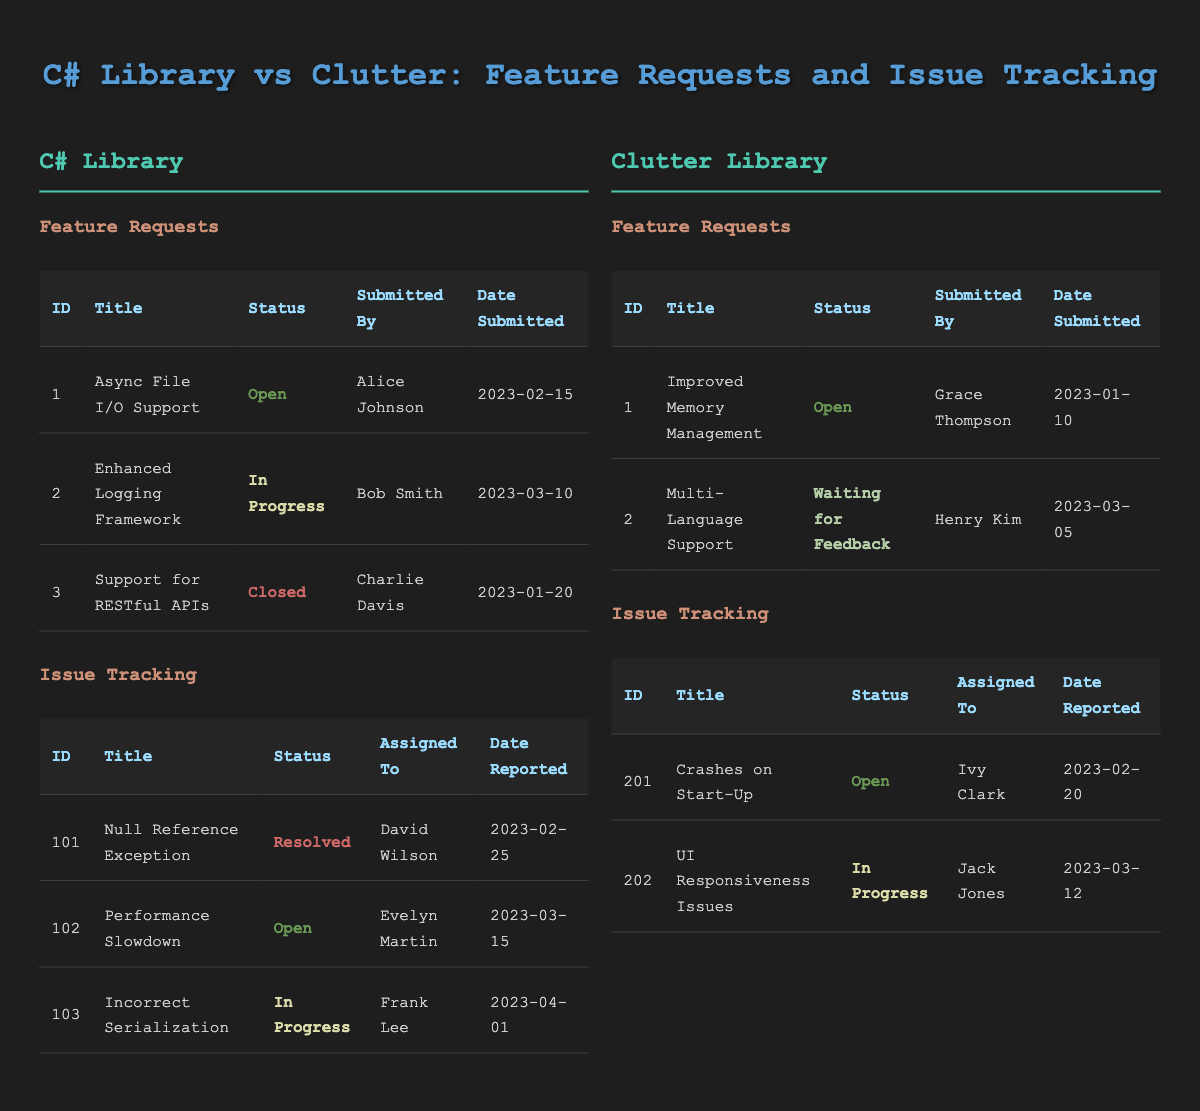What is the title of the first feature request for the C# library? The first feature request in the C# library feature requests table has an ID of 1. Looking at the corresponding title in that row, it is "Async File I/O Support."
Answer: Async File I/O Support How many feature requests are currently open for Clutter? In the Clutter feature requests table, there are two entries. The statuses for each request show that both "Improved Memory Management" and "Multi-Language Support" are open or waiting for feedback. Only the first one is marked as open, so the count is 1.
Answer: 1 Which issue has been resolved in the C# library? By examining the issue tracking table for the C# library, I see that the issue with the title "Null Reference Exception" is marked as resolved. The resolution date is also provided, indicating it was resolved on 2023-03-05.
Answer: Null Reference Exception Are there any feature requests for the C# library that have been resolved or closed? The C# library feature requests table shows three requests. The request titled "Support for RESTful APIs" has a status of closed, which confirms it has been resolved or completed.
Answer: Yes What is the difference in the number of open issues between the C# library and Clutter? The C# library has one open issue titled "Performance Slowdown." In contrast, Clutter library has one open issue titled "Crashes on Start-Up." Since both libraries have the same number of open issues (1), the difference is 0.
Answer: 0 Evaluate whether any feature requests in the C# library have a submission date later than March 1, 2023. In the C# library feature requests, I check the dates: "Async File I/O Support" (2023-02-15) is earlier than March 1, and "Enhanced Logging Framework" (2023-03-10) is later. The final request "Support for RESTful APIs" (2023-01-20) is also earlier. Thus, only one request has a later date.
Answer: Yes What is the total number of issues reported across both libraries? The C# library has three reported issues, and the Clutter library has two reported issues. Adding these together gives a total of 3 + 2 = 5 reported issues across both libraries.
Answer: 5 How many feature requests for Clutter are waiting for feedback? The Clutter feature requests table contains two requests, one of which titled "Multi-Language Support" is marked as waiting for feedback. This indicates that only one request is currently waiting for feedback.
Answer: 1 